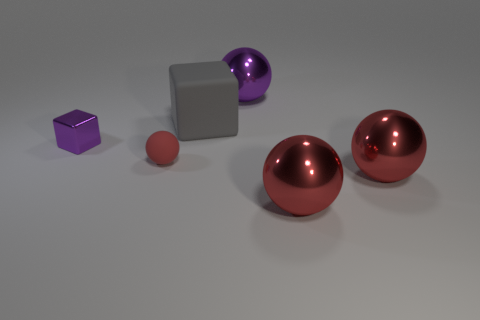There is a thing that is both to the left of the large gray block and behind the red matte thing; what size is it?
Your response must be concise. Small. What material is the block on the right side of the small red ball?
Your answer should be very brief. Rubber. Is there a matte thing of the same shape as the small purple metal object?
Give a very brief answer. Yes. How many other things have the same shape as the small red matte object?
Provide a succinct answer. 3. Is the size of the purple thing that is in front of the large purple metal thing the same as the red object on the left side of the gray matte object?
Provide a succinct answer. Yes. What is the shape of the purple shiny object in front of the matte thing to the right of the small red sphere?
Provide a succinct answer. Cube. Are there the same number of purple metal objects in front of the tiny purple cube and big rubber things?
Make the answer very short. No. There is a red thing that is to the left of the metal thing that is behind the cube left of the gray cube; what is it made of?
Ensure brevity in your answer.  Rubber. Are there any spheres of the same size as the gray matte cube?
Keep it short and to the point. Yes. The large purple shiny object has what shape?
Your response must be concise. Sphere. 